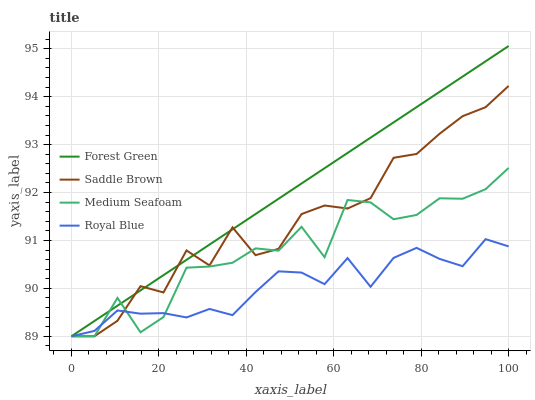Does Royal Blue have the minimum area under the curve?
Answer yes or no. Yes. Does Forest Green have the maximum area under the curve?
Answer yes or no. Yes. Does Saddle Brown have the minimum area under the curve?
Answer yes or no. No. Does Saddle Brown have the maximum area under the curve?
Answer yes or no. No. Is Forest Green the smoothest?
Answer yes or no. Yes. Is Medium Seafoam the roughest?
Answer yes or no. Yes. Is Saddle Brown the smoothest?
Answer yes or no. No. Is Saddle Brown the roughest?
Answer yes or no. No. Does Royal Blue have the lowest value?
Answer yes or no. Yes. Does Forest Green have the highest value?
Answer yes or no. Yes. Does Saddle Brown have the highest value?
Answer yes or no. No. Does Saddle Brown intersect Forest Green?
Answer yes or no. Yes. Is Saddle Brown less than Forest Green?
Answer yes or no. No. Is Saddle Brown greater than Forest Green?
Answer yes or no. No. 